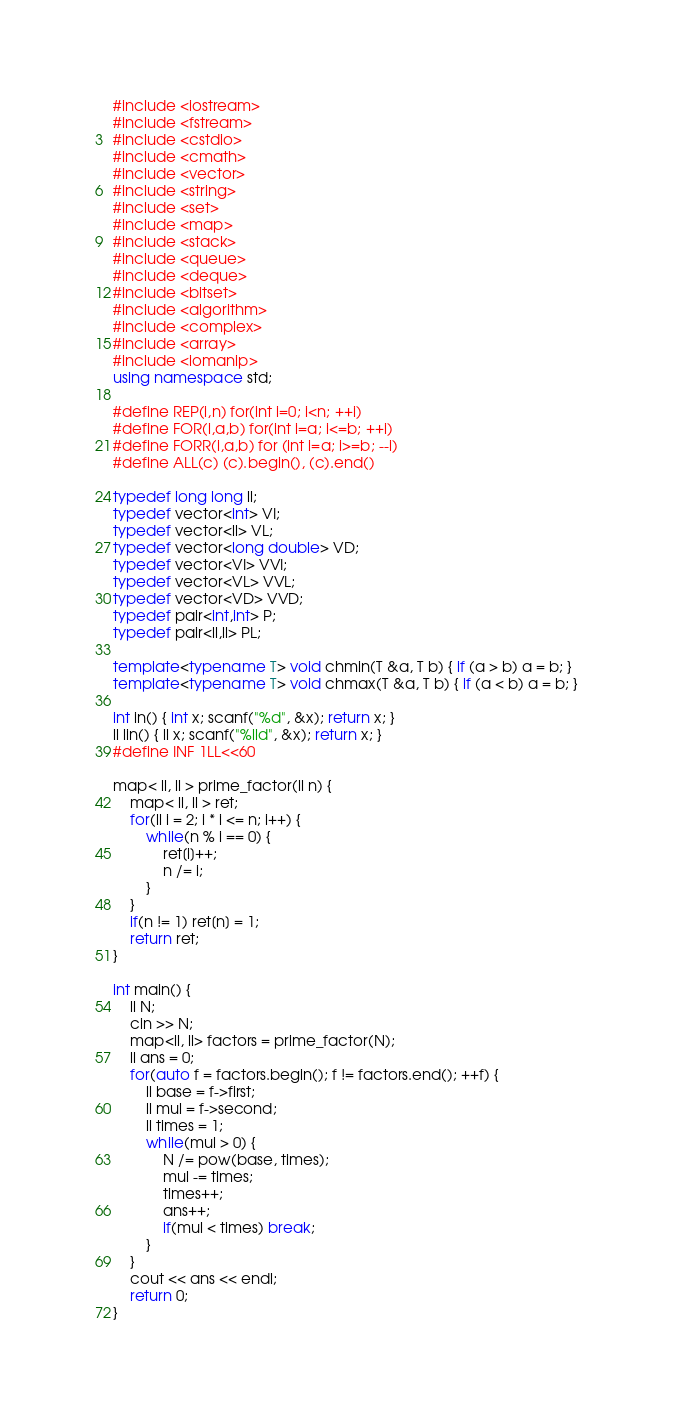<code> <loc_0><loc_0><loc_500><loc_500><_C++_>#include <iostream>
#include <fstream>
#include <cstdio>
#include <cmath>
#include <vector>
#include <string>
#include <set>
#include <map>
#include <stack>
#include <queue>
#include <deque>
#include <bitset>
#include <algorithm>
#include <complex>
#include <array>
#include <iomanip>
using namespace std;

#define REP(i,n) for(int i=0; i<n; ++i)
#define FOR(i,a,b) for(int i=a; i<=b; ++i)
#define FORR(i,a,b) for (int i=a; i>=b; --i)
#define ALL(c) (c).begin(), (c).end()

typedef long long ll;
typedef vector<int> VI;
typedef vector<ll> VL;
typedef vector<long double> VD;
typedef vector<VI> VVI;
typedef vector<VL> VVL;
typedef vector<VD> VVD;
typedef pair<int,int> P;
typedef pair<ll,ll> PL;

template<typename T> void chmin(T &a, T b) { if (a > b) a = b; }
template<typename T> void chmax(T &a, T b) { if (a < b) a = b; }

int in() { int x; scanf("%d", &x); return x; }
ll lin() { ll x; scanf("%lld", &x); return x; }
#define INF 1LL<<60

map< ll, ll > prime_factor(ll n) {
    map< ll, ll > ret;
    for(ll i = 2; i * i <= n; i++) {
        while(n % i == 0) {
            ret[i]++;
            n /= i;
        }
    }
    if(n != 1) ret[n] = 1;
    return ret;
}

int main() {
    ll N;
    cin >> N;
    map<ll, ll> factors = prime_factor(N);
    ll ans = 0;
    for(auto f = factors.begin(); f != factors.end(); ++f) {
        ll base = f->first;
        ll mul = f->second;
        ll times = 1;
        while(mul > 0) {
            N /= pow(base, times);
            mul -= times;
            times++;
            ans++;
            if(mul < times) break;
        }
    }
    cout << ans << endl;
    return 0;
}</code> 